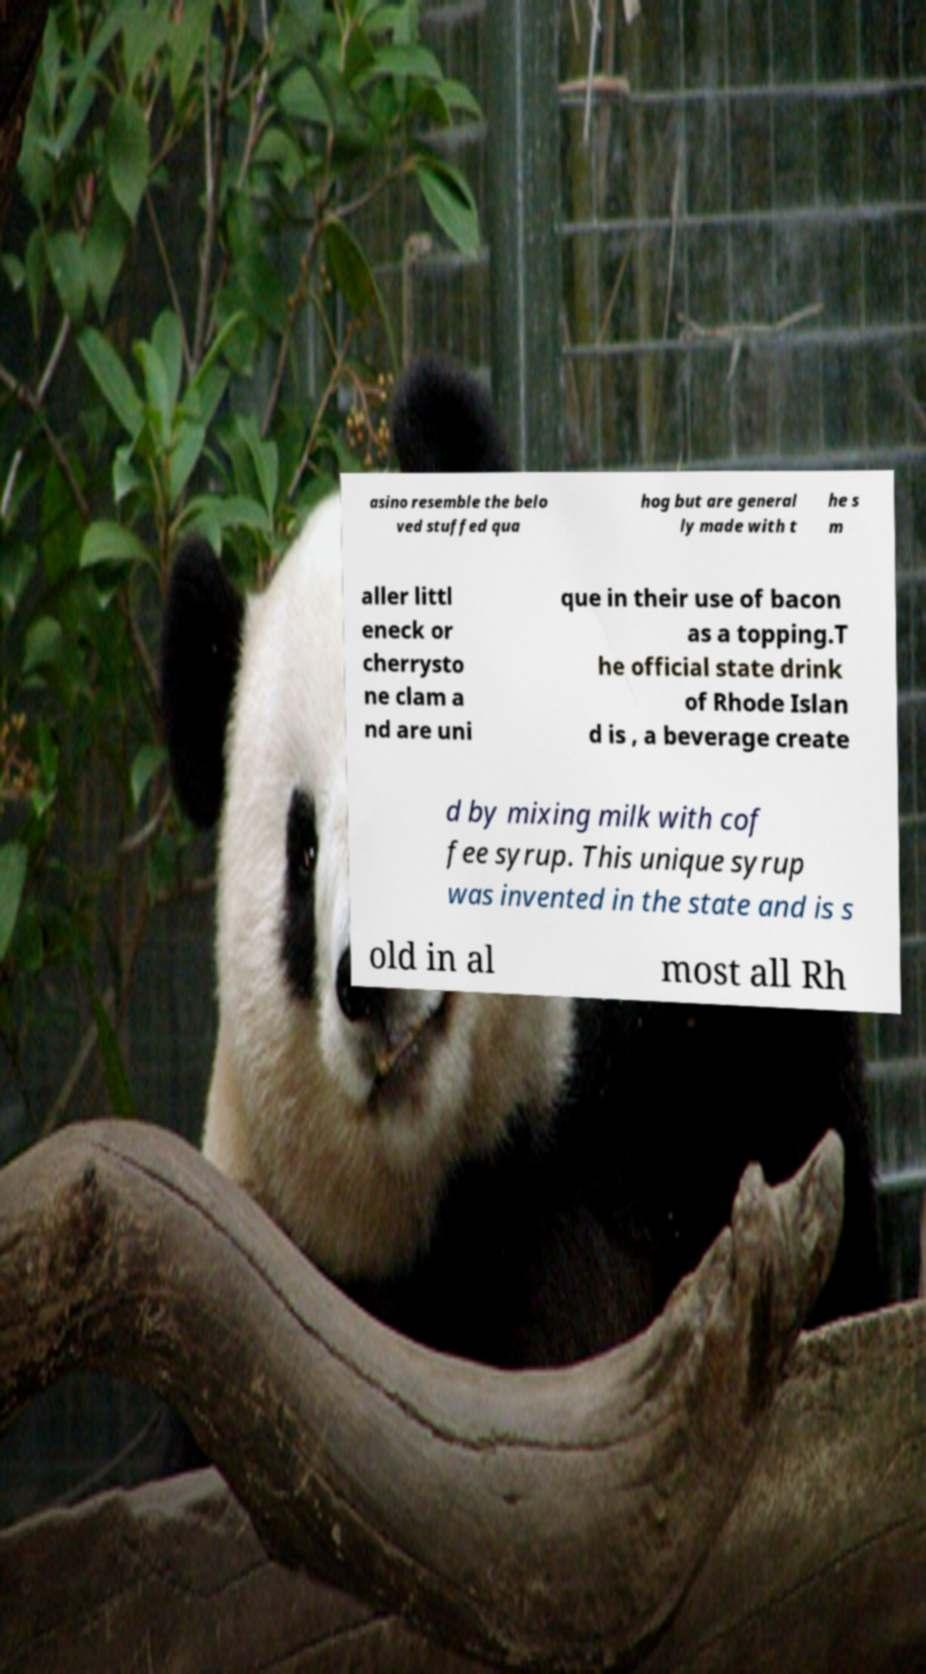There's text embedded in this image that I need extracted. Can you transcribe it verbatim? asino resemble the belo ved stuffed qua hog but are general ly made with t he s m aller littl eneck or cherrysto ne clam a nd are uni que in their use of bacon as a topping.T he official state drink of Rhode Islan d is , a beverage create d by mixing milk with cof fee syrup. This unique syrup was invented in the state and is s old in al most all Rh 